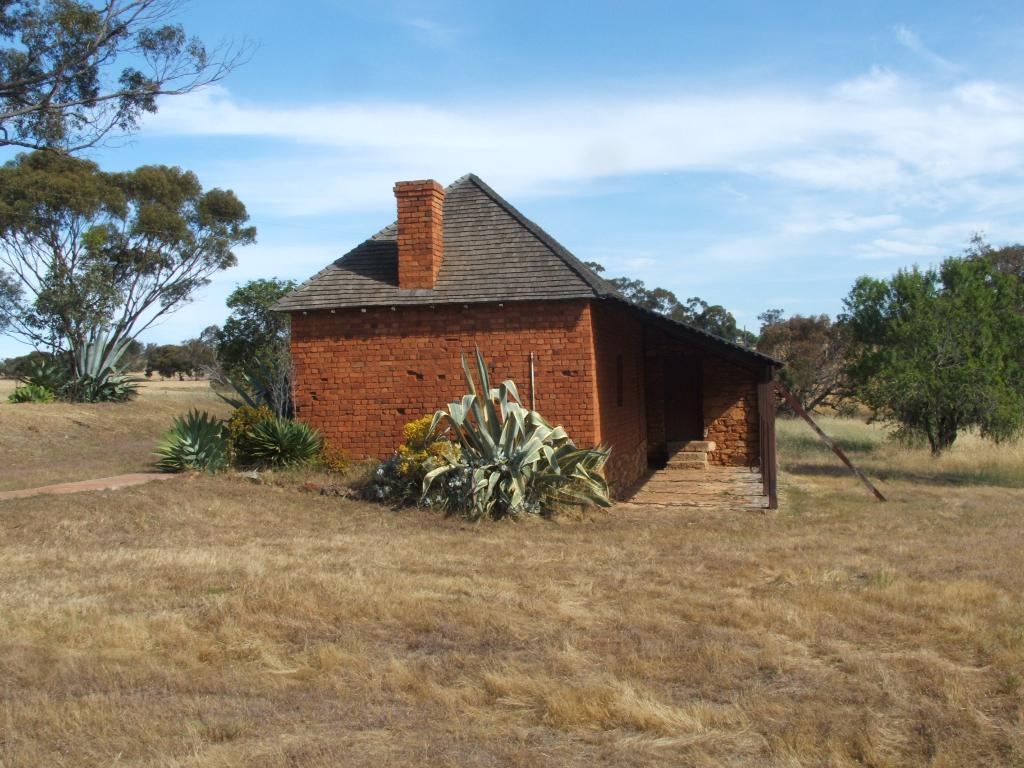Could you give a brief overview of what you see in this image? In this picture we can see a house, there are some rods, there are few trees and plants and the ground is covered with grass with the sky in the background. 